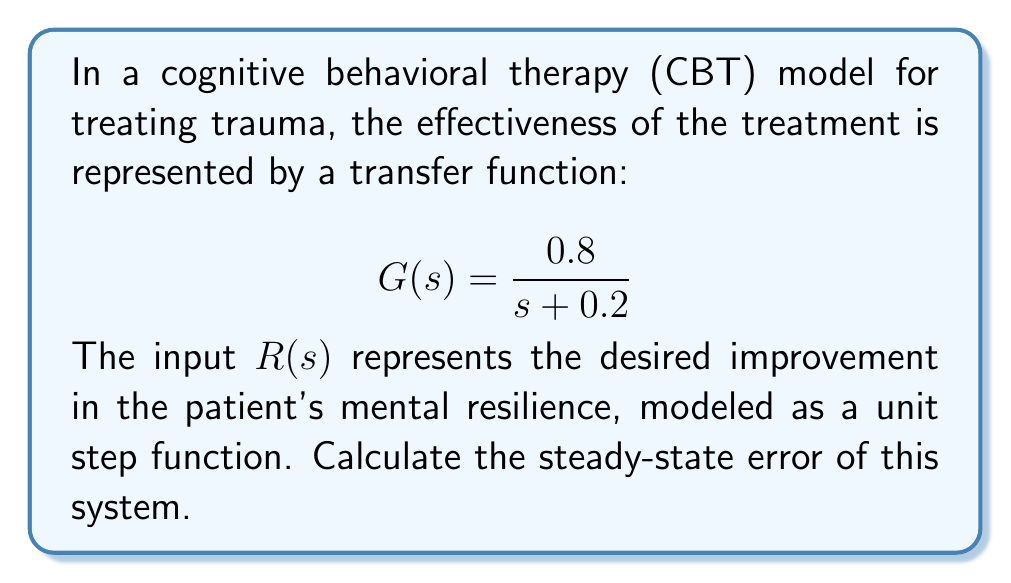Can you solve this math problem? To calculate the steady-state error for a step input, we can use the final value theorem and the concept of the error transfer function.

1. The error transfer function for a unity feedback system is given by:

   $$E(s) = \frac{1}{1 + G(s)}$$

2. Substituting the given transfer function:

   $$E(s) = \frac{1}{1 + \frac{0.8}{s + 0.2}} = \frac{s + 0.2}{s + 1}$$

3. The final value theorem states that for a step input:

   $$e_{ss} = \lim_{s \to 0} sE(s)R(s)$$

   where $R(s) = \frac{1}{s}$ for a unit step input.

4. Applying the final value theorem:

   $$e_{ss} = \lim_{s \to 0} s \cdot \frac{s + 0.2}{s + 1} \cdot \frac{1}{s}$$

5. Simplifying:

   $$e_{ss} = \lim_{s \to 0} \frac{s + 0.2}{s + 1} = \frac{0.2}{1} = 0.2$$

The steady-state error of 0.2 indicates that the CBT model predicts the patient's mental resilience will approach 80% of the desired improvement in the long term, with a persistent 20% gap between the target and achieved resilience.
Answer: The steady-state error is 0.2 or 20%. 